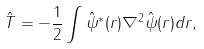<formula> <loc_0><loc_0><loc_500><loc_500>\hat { T } = - \frac { 1 } { 2 } \int \hat { \psi } ^ { \ast } ( { r } ) \nabla ^ { 2 } \hat { \psi } ( { r } ) d { r } ,</formula> 